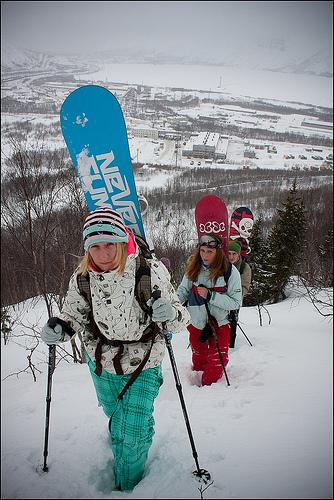Question: how many people are in the picture?
Choices:
A. 3.
B. 6.
C. 1.
D. 0.
Answer with the letter. Answer: A Question: what do the people have on their backs?
Choices:
A. Skis.
B. Snowboards.
C. Backpacks.
D. Coats.
Answer with the letter. Answer: B Question: what season is it in the picture?
Choices:
A. Spring.
B. Summer.
C. Winter.
D. Fall.
Answer with the letter. Answer: C Question: why are the people wearing coats?
Choices:
A. It's snowing.
B. It's cold.
C. It's raining.
D. It's winter.
Answer with the letter. Answer: B 